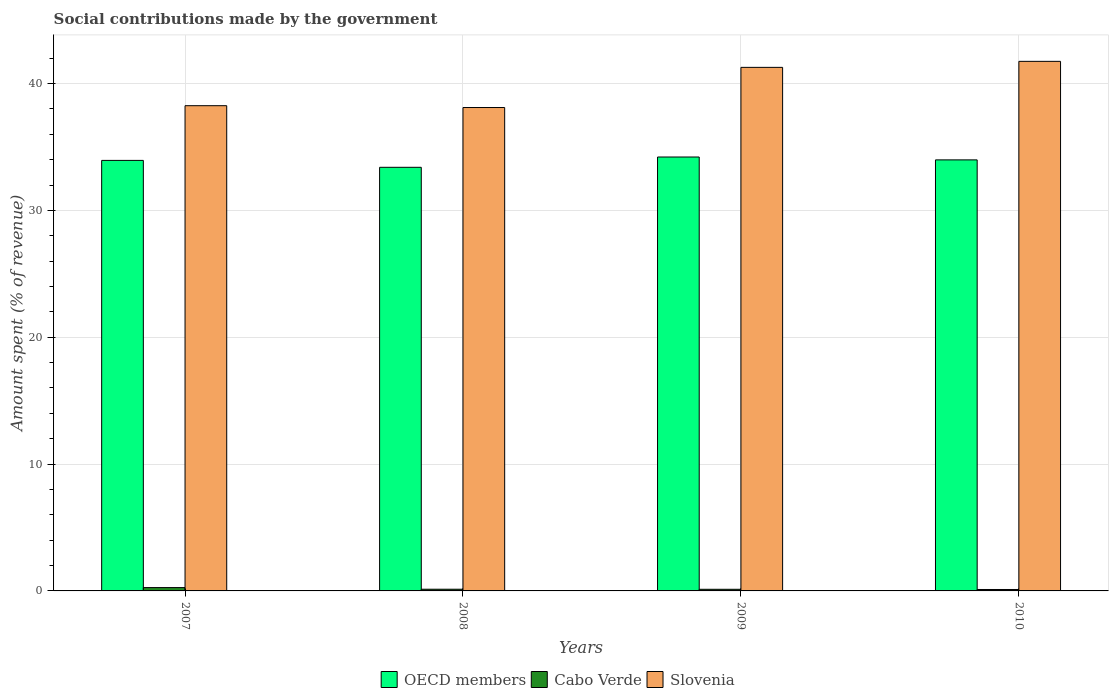How many groups of bars are there?
Your answer should be very brief. 4. Are the number of bars on each tick of the X-axis equal?
Make the answer very short. Yes. How many bars are there on the 4th tick from the right?
Provide a succinct answer. 3. What is the label of the 2nd group of bars from the left?
Provide a short and direct response. 2008. What is the amount spent (in %) on social contributions in Cabo Verde in 2007?
Your answer should be very brief. 0.26. Across all years, what is the maximum amount spent (in %) on social contributions in OECD members?
Offer a very short reply. 34.21. Across all years, what is the minimum amount spent (in %) on social contributions in Slovenia?
Offer a terse response. 38.11. In which year was the amount spent (in %) on social contributions in OECD members minimum?
Ensure brevity in your answer.  2008. What is the total amount spent (in %) on social contributions in OECD members in the graph?
Offer a very short reply. 135.54. What is the difference between the amount spent (in %) on social contributions in Slovenia in 2009 and that in 2010?
Offer a very short reply. -0.47. What is the difference between the amount spent (in %) on social contributions in Cabo Verde in 2010 and the amount spent (in %) on social contributions in Slovenia in 2009?
Provide a short and direct response. -41.17. What is the average amount spent (in %) on social contributions in Slovenia per year?
Offer a terse response. 39.85. In the year 2007, what is the difference between the amount spent (in %) on social contributions in Slovenia and amount spent (in %) on social contributions in Cabo Verde?
Keep it short and to the point. 37.99. What is the ratio of the amount spent (in %) on social contributions in Slovenia in 2007 to that in 2010?
Your response must be concise. 0.92. What is the difference between the highest and the second highest amount spent (in %) on social contributions in OECD members?
Provide a short and direct response. 0.23. What is the difference between the highest and the lowest amount spent (in %) on social contributions in Slovenia?
Keep it short and to the point. 3.64. Is the sum of the amount spent (in %) on social contributions in Cabo Verde in 2007 and 2008 greater than the maximum amount spent (in %) on social contributions in OECD members across all years?
Provide a short and direct response. No. What does the 1st bar from the left in 2008 represents?
Keep it short and to the point. OECD members. What does the 1st bar from the right in 2010 represents?
Make the answer very short. Slovenia. Is it the case that in every year, the sum of the amount spent (in %) on social contributions in Cabo Verde and amount spent (in %) on social contributions in OECD members is greater than the amount spent (in %) on social contributions in Slovenia?
Your response must be concise. No. How many years are there in the graph?
Offer a terse response. 4. Are the values on the major ticks of Y-axis written in scientific E-notation?
Give a very brief answer. No. Does the graph contain grids?
Your answer should be compact. Yes. Where does the legend appear in the graph?
Make the answer very short. Bottom center. How are the legend labels stacked?
Offer a very short reply. Horizontal. What is the title of the graph?
Make the answer very short. Social contributions made by the government. What is the label or title of the X-axis?
Provide a succinct answer. Years. What is the label or title of the Y-axis?
Your response must be concise. Amount spent (% of revenue). What is the Amount spent (% of revenue) of OECD members in 2007?
Keep it short and to the point. 33.94. What is the Amount spent (% of revenue) of Cabo Verde in 2007?
Your answer should be compact. 0.26. What is the Amount spent (% of revenue) in Slovenia in 2007?
Offer a terse response. 38.26. What is the Amount spent (% of revenue) of OECD members in 2008?
Offer a terse response. 33.4. What is the Amount spent (% of revenue) in Cabo Verde in 2008?
Provide a succinct answer. 0.13. What is the Amount spent (% of revenue) of Slovenia in 2008?
Your response must be concise. 38.11. What is the Amount spent (% of revenue) in OECD members in 2009?
Make the answer very short. 34.21. What is the Amount spent (% of revenue) of Cabo Verde in 2009?
Ensure brevity in your answer.  0.13. What is the Amount spent (% of revenue) in Slovenia in 2009?
Provide a succinct answer. 41.28. What is the Amount spent (% of revenue) of OECD members in 2010?
Provide a succinct answer. 33.98. What is the Amount spent (% of revenue) of Cabo Verde in 2010?
Keep it short and to the point. 0.11. What is the Amount spent (% of revenue) of Slovenia in 2010?
Offer a very short reply. 41.75. Across all years, what is the maximum Amount spent (% of revenue) of OECD members?
Your answer should be compact. 34.21. Across all years, what is the maximum Amount spent (% of revenue) in Cabo Verde?
Your response must be concise. 0.26. Across all years, what is the maximum Amount spent (% of revenue) of Slovenia?
Provide a short and direct response. 41.75. Across all years, what is the minimum Amount spent (% of revenue) in OECD members?
Offer a terse response. 33.4. Across all years, what is the minimum Amount spent (% of revenue) of Cabo Verde?
Provide a succinct answer. 0.11. Across all years, what is the minimum Amount spent (% of revenue) in Slovenia?
Make the answer very short. 38.11. What is the total Amount spent (% of revenue) of OECD members in the graph?
Give a very brief answer. 135.54. What is the total Amount spent (% of revenue) in Cabo Verde in the graph?
Ensure brevity in your answer.  0.64. What is the total Amount spent (% of revenue) of Slovenia in the graph?
Your response must be concise. 159.4. What is the difference between the Amount spent (% of revenue) of OECD members in 2007 and that in 2008?
Your answer should be very brief. 0.54. What is the difference between the Amount spent (% of revenue) of Cabo Verde in 2007 and that in 2008?
Offer a terse response. 0.13. What is the difference between the Amount spent (% of revenue) in Slovenia in 2007 and that in 2008?
Provide a short and direct response. 0.14. What is the difference between the Amount spent (% of revenue) of OECD members in 2007 and that in 2009?
Make the answer very short. -0.27. What is the difference between the Amount spent (% of revenue) of Cabo Verde in 2007 and that in 2009?
Provide a succinct answer. 0.13. What is the difference between the Amount spent (% of revenue) in Slovenia in 2007 and that in 2009?
Provide a succinct answer. -3.02. What is the difference between the Amount spent (% of revenue) of OECD members in 2007 and that in 2010?
Give a very brief answer. -0.04. What is the difference between the Amount spent (% of revenue) in Cabo Verde in 2007 and that in 2010?
Ensure brevity in your answer.  0.15. What is the difference between the Amount spent (% of revenue) in Slovenia in 2007 and that in 2010?
Offer a very short reply. -3.5. What is the difference between the Amount spent (% of revenue) in OECD members in 2008 and that in 2009?
Your answer should be compact. -0.81. What is the difference between the Amount spent (% of revenue) of Cabo Verde in 2008 and that in 2009?
Your response must be concise. 0. What is the difference between the Amount spent (% of revenue) in Slovenia in 2008 and that in 2009?
Your response must be concise. -3.17. What is the difference between the Amount spent (% of revenue) in OECD members in 2008 and that in 2010?
Provide a succinct answer. -0.58. What is the difference between the Amount spent (% of revenue) in Cabo Verde in 2008 and that in 2010?
Make the answer very short. 0.02. What is the difference between the Amount spent (% of revenue) in Slovenia in 2008 and that in 2010?
Provide a succinct answer. -3.64. What is the difference between the Amount spent (% of revenue) of OECD members in 2009 and that in 2010?
Your response must be concise. 0.23. What is the difference between the Amount spent (% of revenue) of Cabo Verde in 2009 and that in 2010?
Give a very brief answer. 0.02. What is the difference between the Amount spent (% of revenue) in Slovenia in 2009 and that in 2010?
Offer a terse response. -0.47. What is the difference between the Amount spent (% of revenue) of OECD members in 2007 and the Amount spent (% of revenue) of Cabo Verde in 2008?
Provide a succinct answer. 33.81. What is the difference between the Amount spent (% of revenue) of OECD members in 2007 and the Amount spent (% of revenue) of Slovenia in 2008?
Keep it short and to the point. -4.17. What is the difference between the Amount spent (% of revenue) of Cabo Verde in 2007 and the Amount spent (% of revenue) of Slovenia in 2008?
Offer a very short reply. -37.85. What is the difference between the Amount spent (% of revenue) of OECD members in 2007 and the Amount spent (% of revenue) of Cabo Verde in 2009?
Your answer should be very brief. 33.81. What is the difference between the Amount spent (% of revenue) in OECD members in 2007 and the Amount spent (% of revenue) in Slovenia in 2009?
Keep it short and to the point. -7.34. What is the difference between the Amount spent (% of revenue) of Cabo Verde in 2007 and the Amount spent (% of revenue) of Slovenia in 2009?
Keep it short and to the point. -41.02. What is the difference between the Amount spent (% of revenue) in OECD members in 2007 and the Amount spent (% of revenue) in Cabo Verde in 2010?
Your answer should be compact. 33.83. What is the difference between the Amount spent (% of revenue) in OECD members in 2007 and the Amount spent (% of revenue) in Slovenia in 2010?
Ensure brevity in your answer.  -7.81. What is the difference between the Amount spent (% of revenue) of Cabo Verde in 2007 and the Amount spent (% of revenue) of Slovenia in 2010?
Offer a very short reply. -41.49. What is the difference between the Amount spent (% of revenue) of OECD members in 2008 and the Amount spent (% of revenue) of Cabo Verde in 2009?
Make the answer very short. 33.27. What is the difference between the Amount spent (% of revenue) of OECD members in 2008 and the Amount spent (% of revenue) of Slovenia in 2009?
Provide a short and direct response. -7.88. What is the difference between the Amount spent (% of revenue) of Cabo Verde in 2008 and the Amount spent (% of revenue) of Slovenia in 2009?
Keep it short and to the point. -41.15. What is the difference between the Amount spent (% of revenue) in OECD members in 2008 and the Amount spent (% of revenue) in Cabo Verde in 2010?
Offer a terse response. 33.29. What is the difference between the Amount spent (% of revenue) of OECD members in 2008 and the Amount spent (% of revenue) of Slovenia in 2010?
Give a very brief answer. -8.35. What is the difference between the Amount spent (% of revenue) of Cabo Verde in 2008 and the Amount spent (% of revenue) of Slovenia in 2010?
Give a very brief answer. -41.62. What is the difference between the Amount spent (% of revenue) of OECD members in 2009 and the Amount spent (% of revenue) of Cabo Verde in 2010?
Your response must be concise. 34.1. What is the difference between the Amount spent (% of revenue) in OECD members in 2009 and the Amount spent (% of revenue) in Slovenia in 2010?
Ensure brevity in your answer.  -7.54. What is the difference between the Amount spent (% of revenue) in Cabo Verde in 2009 and the Amount spent (% of revenue) in Slovenia in 2010?
Ensure brevity in your answer.  -41.62. What is the average Amount spent (% of revenue) of OECD members per year?
Offer a very short reply. 33.88. What is the average Amount spent (% of revenue) of Cabo Verde per year?
Offer a terse response. 0.16. What is the average Amount spent (% of revenue) of Slovenia per year?
Give a very brief answer. 39.85. In the year 2007, what is the difference between the Amount spent (% of revenue) in OECD members and Amount spent (% of revenue) in Cabo Verde?
Your answer should be very brief. 33.68. In the year 2007, what is the difference between the Amount spent (% of revenue) in OECD members and Amount spent (% of revenue) in Slovenia?
Make the answer very short. -4.31. In the year 2007, what is the difference between the Amount spent (% of revenue) of Cabo Verde and Amount spent (% of revenue) of Slovenia?
Provide a short and direct response. -37.99. In the year 2008, what is the difference between the Amount spent (% of revenue) of OECD members and Amount spent (% of revenue) of Cabo Verde?
Keep it short and to the point. 33.27. In the year 2008, what is the difference between the Amount spent (% of revenue) in OECD members and Amount spent (% of revenue) in Slovenia?
Ensure brevity in your answer.  -4.71. In the year 2008, what is the difference between the Amount spent (% of revenue) of Cabo Verde and Amount spent (% of revenue) of Slovenia?
Ensure brevity in your answer.  -37.98. In the year 2009, what is the difference between the Amount spent (% of revenue) of OECD members and Amount spent (% of revenue) of Cabo Verde?
Ensure brevity in your answer.  34.08. In the year 2009, what is the difference between the Amount spent (% of revenue) in OECD members and Amount spent (% of revenue) in Slovenia?
Provide a succinct answer. -7.07. In the year 2009, what is the difference between the Amount spent (% of revenue) in Cabo Verde and Amount spent (% of revenue) in Slovenia?
Offer a terse response. -41.15. In the year 2010, what is the difference between the Amount spent (% of revenue) of OECD members and Amount spent (% of revenue) of Cabo Verde?
Provide a succinct answer. 33.87. In the year 2010, what is the difference between the Amount spent (% of revenue) in OECD members and Amount spent (% of revenue) in Slovenia?
Ensure brevity in your answer.  -7.77. In the year 2010, what is the difference between the Amount spent (% of revenue) of Cabo Verde and Amount spent (% of revenue) of Slovenia?
Provide a succinct answer. -41.64. What is the ratio of the Amount spent (% of revenue) of OECD members in 2007 to that in 2008?
Your response must be concise. 1.02. What is the ratio of the Amount spent (% of revenue) in Cabo Verde in 2007 to that in 2008?
Ensure brevity in your answer.  1.96. What is the ratio of the Amount spent (% of revenue) in Slovenia in 2007 to that in 2008?
Your answer should be very brief. 1. What is the ratio of the Amount spent (% of revenue) in OECD members in 2007 to that in 2009?
Provide a succinct answer. 0.99. What is the ratio of the Amount spent (% of revenue) of Cabo Verde in 2007 to that in 2009?
Keep it short and to the point. 2.03. What is the ratio of the Amount spent (% of revenue) of Slovenia in 2007 to that in 2009?
Provide a succinct answer. 0.93. What is the ratio of the Amount spent (% of revenue) of OECD members in 2007 to that in 2010?
Keep it short and to the point. 1. What is the ratio of the Amount spent (% of revenue) in Cabo Verde in 2007 to that in 2010?
Your answer should be very brief. 2.33. What is the ratio of the Amount spent (% of revenue) of Slovenia in 2007 to that in 2010?
Offer a terse response. 0.92. What is the ratio of the Amount spent (% of revenue) of OECD members in 2008 to that in 2009?
Your answer should be compact. 0.98. What is the ratio of the Amount spent (% of revenue) of Cabo Verde in 2008 to that in 2009?
Provide a succinct answer. 1.04. What is the ratio of the Amount spent (% of revenue) of Slovenia in 2008 to that in 2009?
Make the answer very short. 0.92. What is the ratio of the Amount spent (% of revenue) of OECD members in 2008 to that in 2010?
Provide a succinct answer. 0.98. What is the ratio of the Amount spent (% of revenue) of Cabo Verde in 2008 to that in 2010?
Your answer should be very brief. 1.19. What is the ratio of the Amount spent (% of revenue) in Slovenia in 2008 to that in 2010?
Keep it short and to the point. 0.91. What is the ratio of the Amount spent (% of revenue) in Cabo Verde in 2009 to that in 2010?
Provide a succinct answer. 1.15. What is the ratio of the Amount spent (% of revenue) of Slovenia in 2009 to that in 2010?
Offer a very short reply. 0.99. What is the difference between the highest and the second highest Amount spent (% of revenue) in OECD members?
Offer a very short reply. 0.23. What is the difference between the highest and the second highest Amount spent (% of revenue) of Cabo Verde?
Ensure brevity in your answer.  0.13. What is the difference between the highest and the second highest Amount spent (% of revenue) of Slovenia?
Offer a terse response. 0.47. What is the difference between the highest and the lowest Amount spent (% of revenue) in OECD members?
Offer a very short reply. 0.81. What is the difference between the highest and the lowest Amount spent (% of revenue) in Cabo Verde?
Your response must be concise. 0.15. What is the difference between the highest and the lowest Amount spent (% of revenue) of Slovenia?
Offer a terse response. 3.64. 